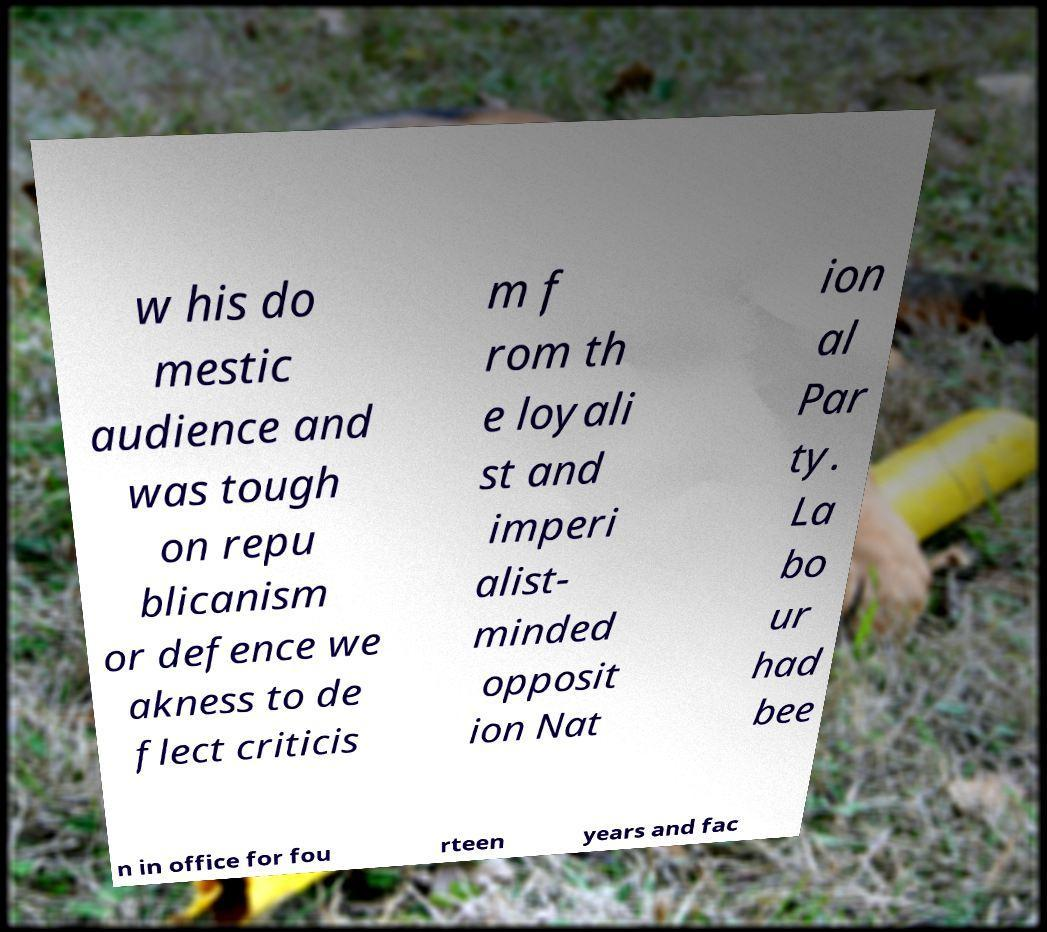For documentation purposes, I need the text within this image transcribed. Could you provide that? w his do mestic audience and was tough on repu blicanism or defence we akness to de flect criticis m f rom th e loyali st and imperi alist- minded opposit ion Nat ion al Par ty. La bo ur had bee n in office for fou rteen years and fac 